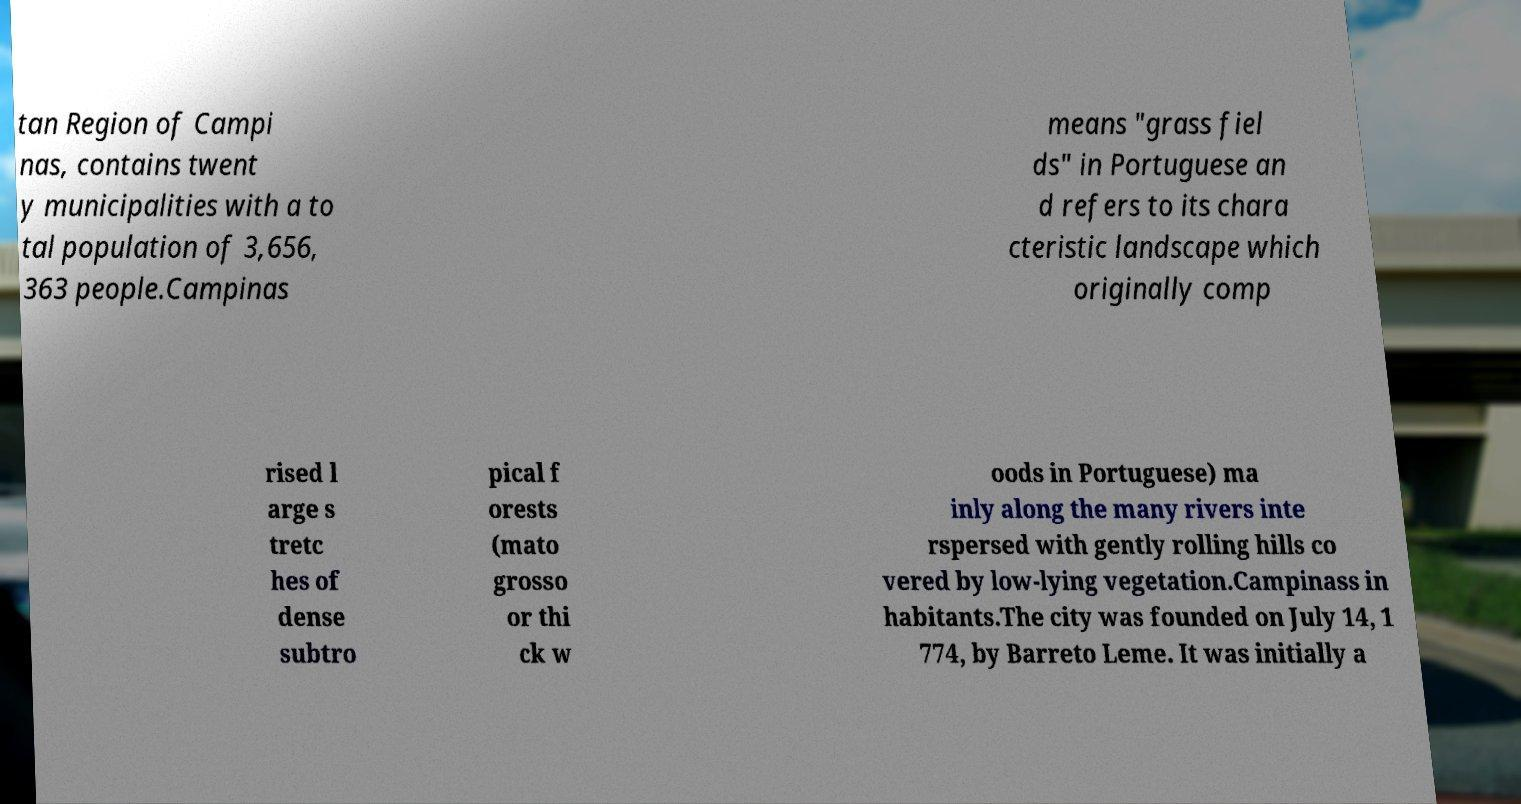There's text embedded in this image that I need extracted. Can you transcribe it verbatim? tan Region of Campi nas, contains twent y municipalities with a to tal population of 3,656, 363 people.Campinas means "grass fiel ds" in Portuguese an d refers to its chara cteristic landscape which originally comp rised l arge s tretc hes of dense subtro pical f orests (mato grosso or thi ck w oods in Portuguese) ma inly along the many rivers inte rspersed with gently rolling hills co vered by low-lying vegetation.Campinass in habitants.The city was founded on July 14, 1 774, by Barreto Leme. It was initially a 